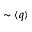Convert formula to latex. <formula><loc_0><loc_0><loc_500><loc_500>\sim \langle q \rangle</formula> 